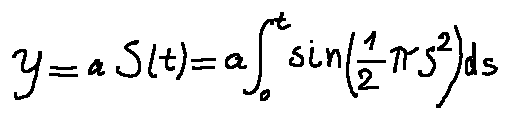<formula> <loc_0><loc_0><loc_500><loc_500>y = a S ( t ) = a \int \lim i t s _ { 0 } ^ { t } \sin ( \frac { 1 } { 2 } \pi s ^ { 2 } ) d s</formula> 